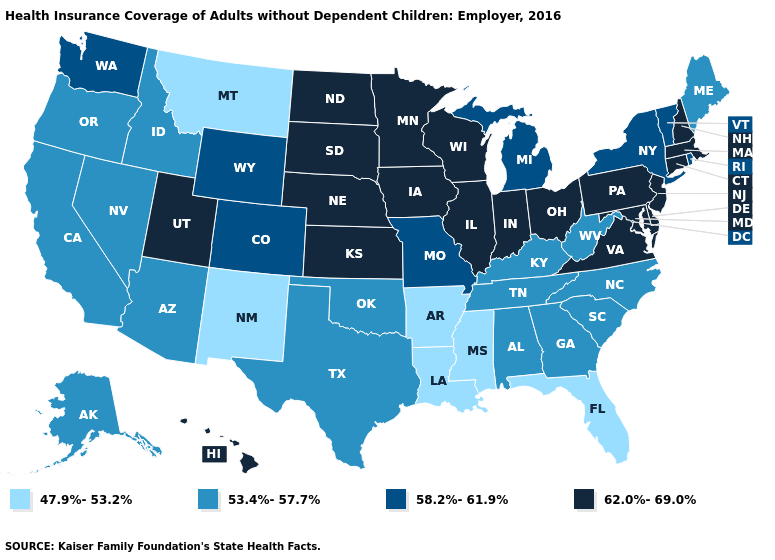What is the value of New York?
Quick response, please. 58.2%-61.9%. What is the value of Connecticut?
Quick response, please. 62.0%-69.0%. Among the states that border Rhode Island , which have the highest value?
Quick response, please. Connecticut, Massachusetts. Does Nebraska have the lowest value in the MidWest?
Concise answer only. No. What is the value of Kansas?
Concise answer only. 62.0%-69.0%. Name the states that have a value in the range 53.4%-57.7%?
Write a very short answer. Alabama, Alaska, Arizona, California, Georgia, Idaho, Kentucky, Maine, Nevada, North Carolina, Oklahoma, Oregon, South Carolina, Tennessee, Texas, West Virginia. What is the lowest value in the USA?
Short answer required. 47.9%-53.2%. Does Arkansas have the highest value in the USA?
Write a very short answer. No. Among the states that border Missouri , does Oklahoma have the highest value?
Be succinct. No. Does Nebraska have the lowest value in the USA?
Give a very brief answer. No. Among the states that border West Virginia , does Ohio have the highest value?
Give a very brief answer. Yes. Among the states that border Pennsylvania , does New York have the highest value?
Short answer required. No. Name the states that have a value in the range 53.4%-57.7%?
Write a very short answer. Alabama, Alaska, Arizona, California, Georgia, Idaho, Kentucky, Maine, Nevada, North Carolina, Oklahoma, Oregon, South Carolina, Tennessee, Texas, West Virginia. What is the value of Wisconsin?
Short answer required. 62.0%-69.0%. What is the value of New Hampshire?
Short answer required. 62.0%-69.0%. 